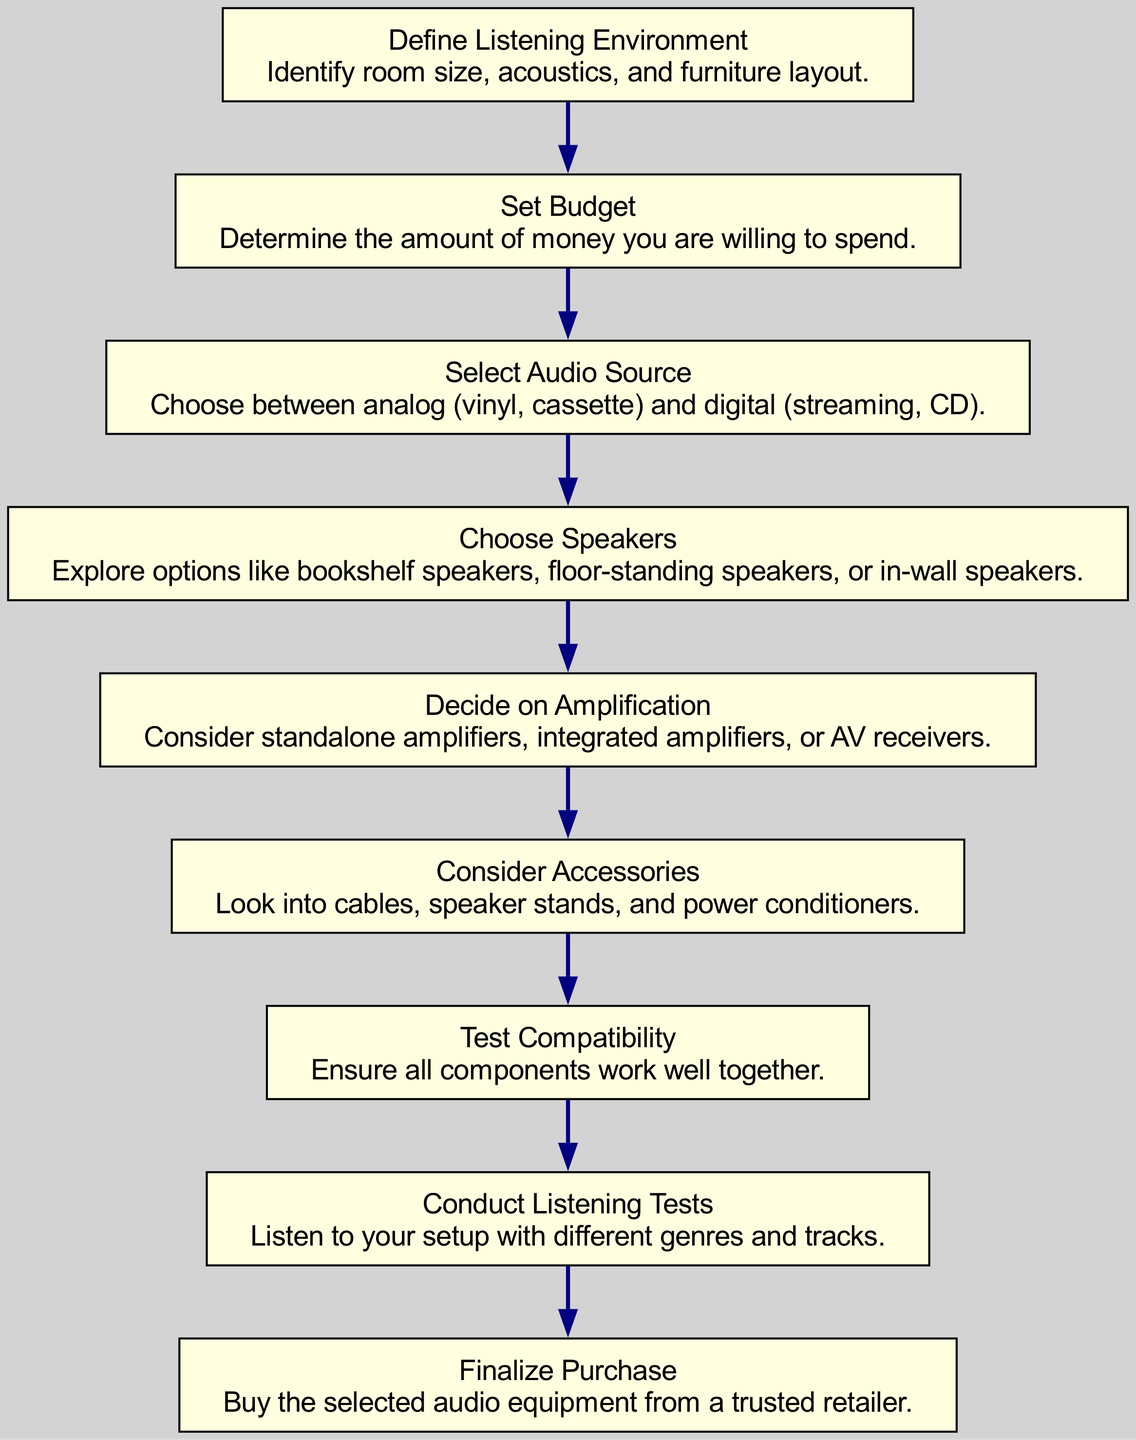What is the first step in the flow chart? The diagram starts with the node labeled "Define Listening Environment." This is the first node, and it sets the stage for all subsequent actions in the flow.
Answer: Define Listening Environment How many total nodes are there in the diagram? By counting all the mentioned elements in the diagram, we find a total of nine nodes, each representing a different step in the audio equipment selection process.
Answer: Nine What should you consider after setting your budget? According to the flow, after you set your budget, the next step is to select an audio source, which means deciding between analog and digital options.
Answer: Select Audio Source Which step involves testing the audio equipment? The step regarding conducting listening tests is specifically focused on evaluating the audio setup with various genres and tracks. This involves critical listening to assess sound quality.
Answer: Conduct Listening Tests What is the last action in the flow chart? The flow chart concludes with the step labeled "Finalize Purchase," which signifies the last action in the selection process where one buys the chosen audio equipment.
Answer: Finalize Purchase What is the relationship between "Choose Speakers" and "Decide on Amplification"? "Choose Speakers" comes before "Decide on Amplification" in the diagram. This indicates that the choice of speakers informs the amplification decision in the audio setup process.
Answer: Choose Speakers → Decide on Amplification What is required before conducting listening tests? Before you can conduct listening tests, you need to test the compatibility of all components to ensure they work well together, making it vital to check before the listening phase.
Answer: Test Compatibility Which nodes deal with additional audio equipment and components? The nodes that address additional audio equipment and accessories are "Consider Accessories" and "Decide on Amplification," both of which focus on the broader setup beyond just speakers and source.
Answer: Consider Accessories, Decide on Amplification 